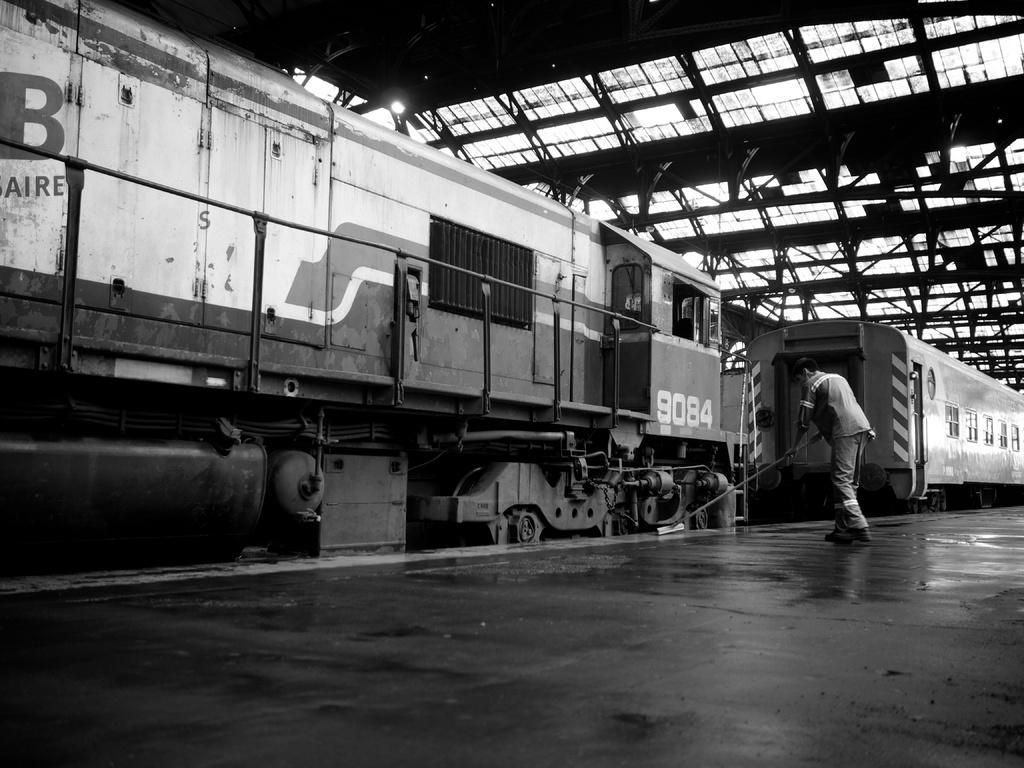Could you give a brief overview of what you see in this image? In this image we can see a person holding the object and cleaning the platform in the railway station, in front of the person there is a train, on the top there is a roof with light. 